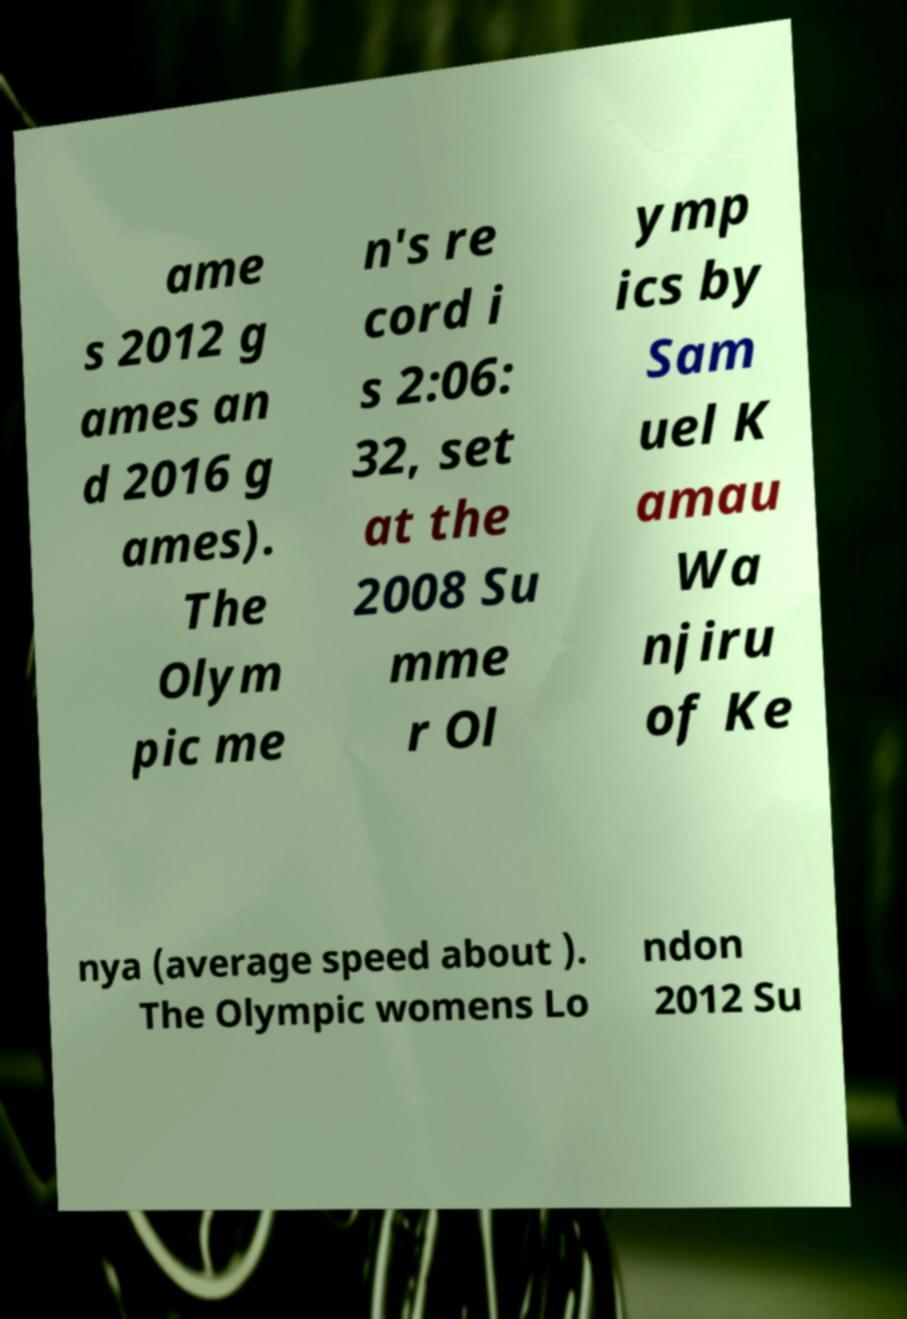Please identify and transcribe the text found in this image. ame s 2012 g ames an d 2016 g ames). The Olym pic me n's re cord i s 2:06: 32, set at the 2008 Su mme r Ol ymp ics by Sam uel K amau Wa njiru of Ke nya (average speed about ). The Olympic womens Lo ndon 2012 Su 